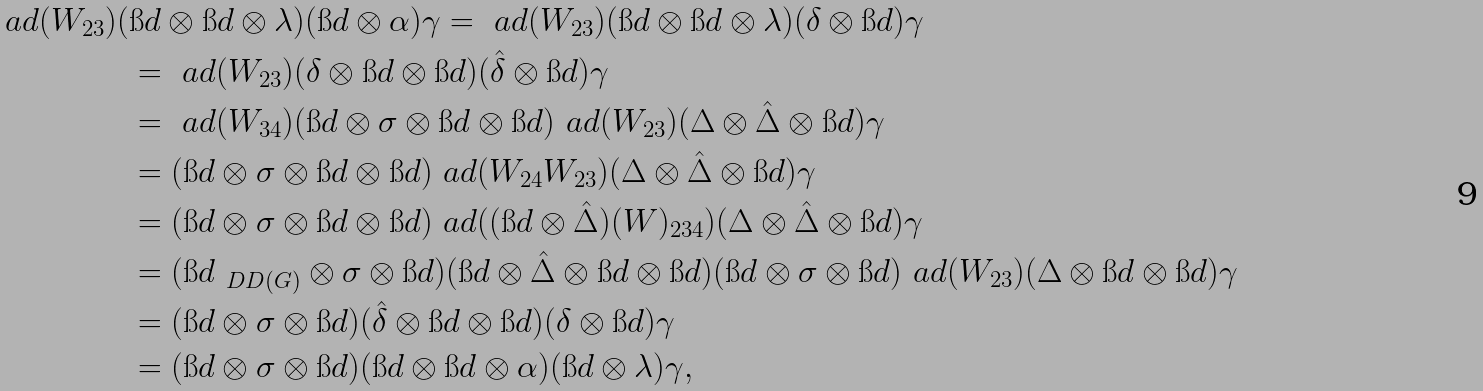<formula> <loc_0><loc_0><loc_500><loc_500>\ a d ( W _ { 2 3 } ) ( & \i d \otimes \i d \otimes \lambda ) ( \i d \otimes \alpha ) \gamma = \ a d ( W _ { 2 3 } ) ( \i d \otimes \i d \otimes \lambda ) ( \delta \otimes \i d ) \gamma \\ & = \ a d ( W _ { 2 3 } ) ( \delta \otimes \i d \otimes \i d ) ( \hat { \delta } \otimes \i d ) \gamma \\ & = \ a d ( W _ { 3 4 } ) ( \i d \otimes \sigma \otimes \i d \otimes \i d ) \ a d ( W _ { 2 3 } ) ( \Delta \otimes \hat { \Delta } \otimes \i d ) \gamma \\ & = ( \i d \otimes \sigma \otimes \i d \otimes \i d ) \ a d ( W _ { 2 4 } W _ { 2 3 } ) ( \Delta \otimes \hat { \Delta } \otimes \i d ) \gamma \\ & = ( \i d \otimes \sigma \otimes \i d \otimes \i d ) \ a d ( ( \i d \otimes \hat { \Delta } ) ( W ) _ { 2 3 4 } ) ( \Delta \otimes \hat { \Delta } \otimes \i d ) \gamma \\ & = ( \i d _ { \ D D ( G ) } \otimes \sigma \otimes \i d ) ( \i d \otimes \hat { \Delta } \otimes \i d \otimes \i d ) ( \i d \otimes \sigma \otimes \i d ) \ a d ( W _ { 2 3 } ) ( \Delta \otimes \i d \otimes \i d ) \gamma \\ & = ( \i d \otimes \sigma \otimes \i d ) ( \hat { \delta } \otimes \i d \otimes \i d ) ( \delta \otimes \i d ) \gamma \\ & = ( \i d \otimes \sigma \otimes \i d ) ( \i d \otimes \i d \otimes \alpha ) ( \i d \otimes \lambda ) \gamma ,</formula> 